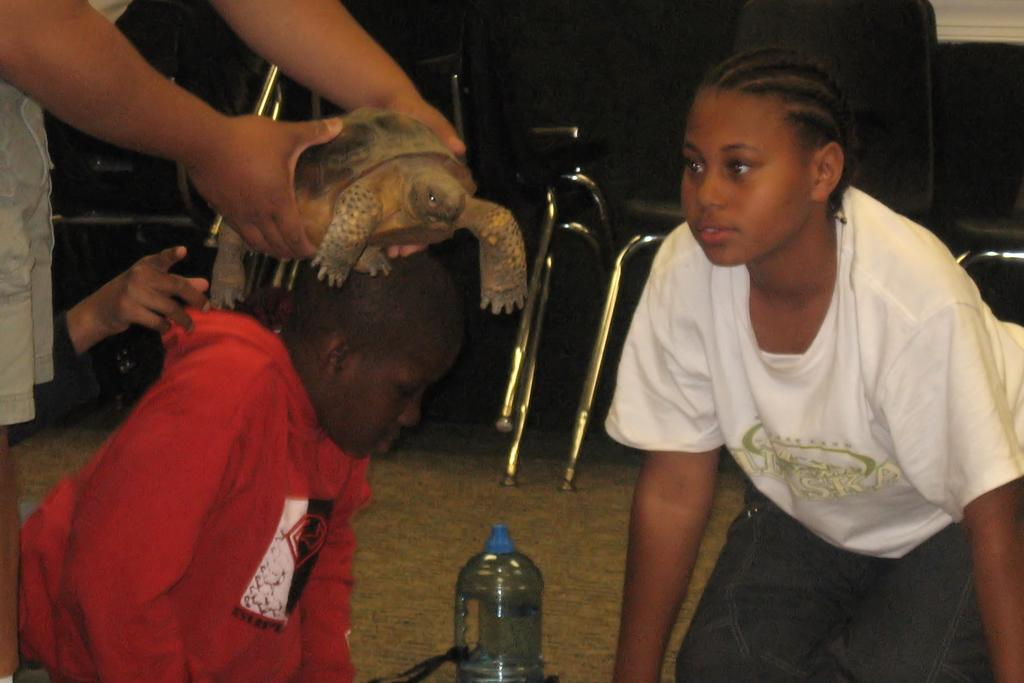How many kids are present in the image? There are two kids in the image. What is happening to one of the kids in the image? A guy is placing a tortoise on the head of one of the kids. What can be seen in the background of the image? There are unoccupied chairs in the background of the image. Where are the sheep located in the image? There are no sheep present in the image. What type of wire is being used to hold the tortoise in the image? There is no wire present in the image; the tortoise is being placed directly on the kid's head. 